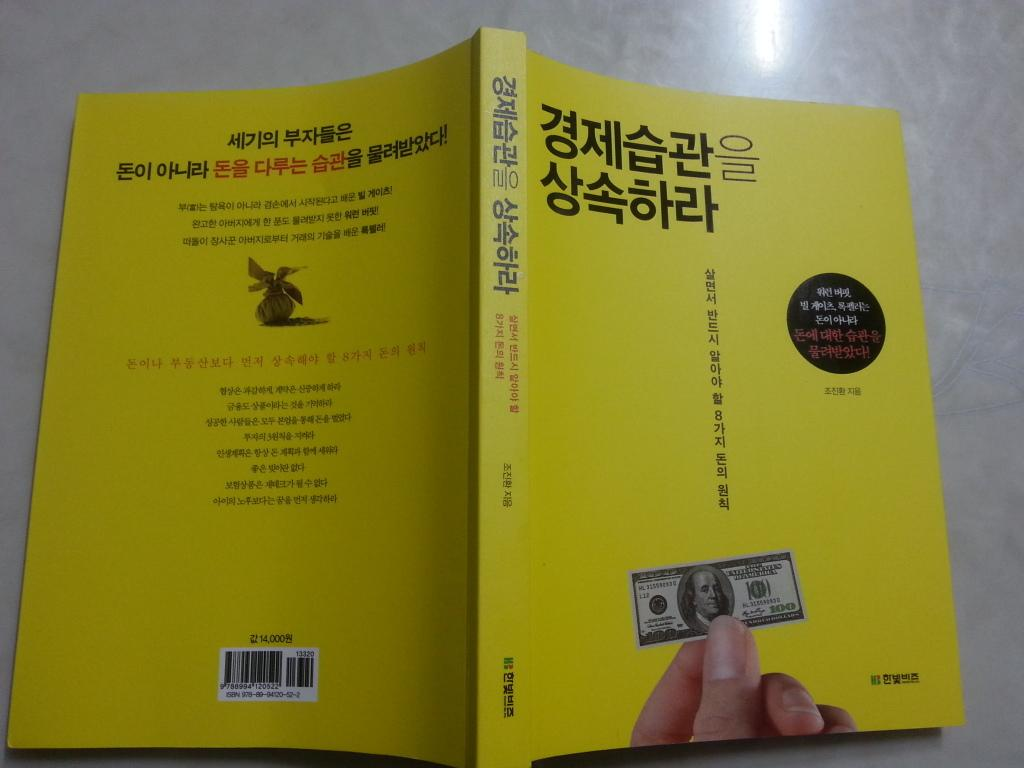<image>
Render a clear and concise summary of the photo. A book in Chinese shows a picture of a 100 dollar United States Bill on the cover 